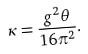Convert formula to latex. <formula><loc_0><loc_0><loc_500><loc_500>\kappa = \frac { g ^ { 2 } \theta } { 1 6 \pi ^ { 2 } } .</formula> 